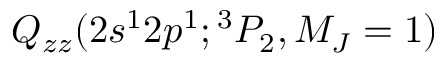Convert formula to latex. <formula><loc_0><loc_0><loc_500><loc_500>Q _ { z z } ( 2 s ^ { 1 } 2 p ^ { 1 } ; { ^ { 3 } P _ { 2 } , M _ { J } = 1 } )</formula> 